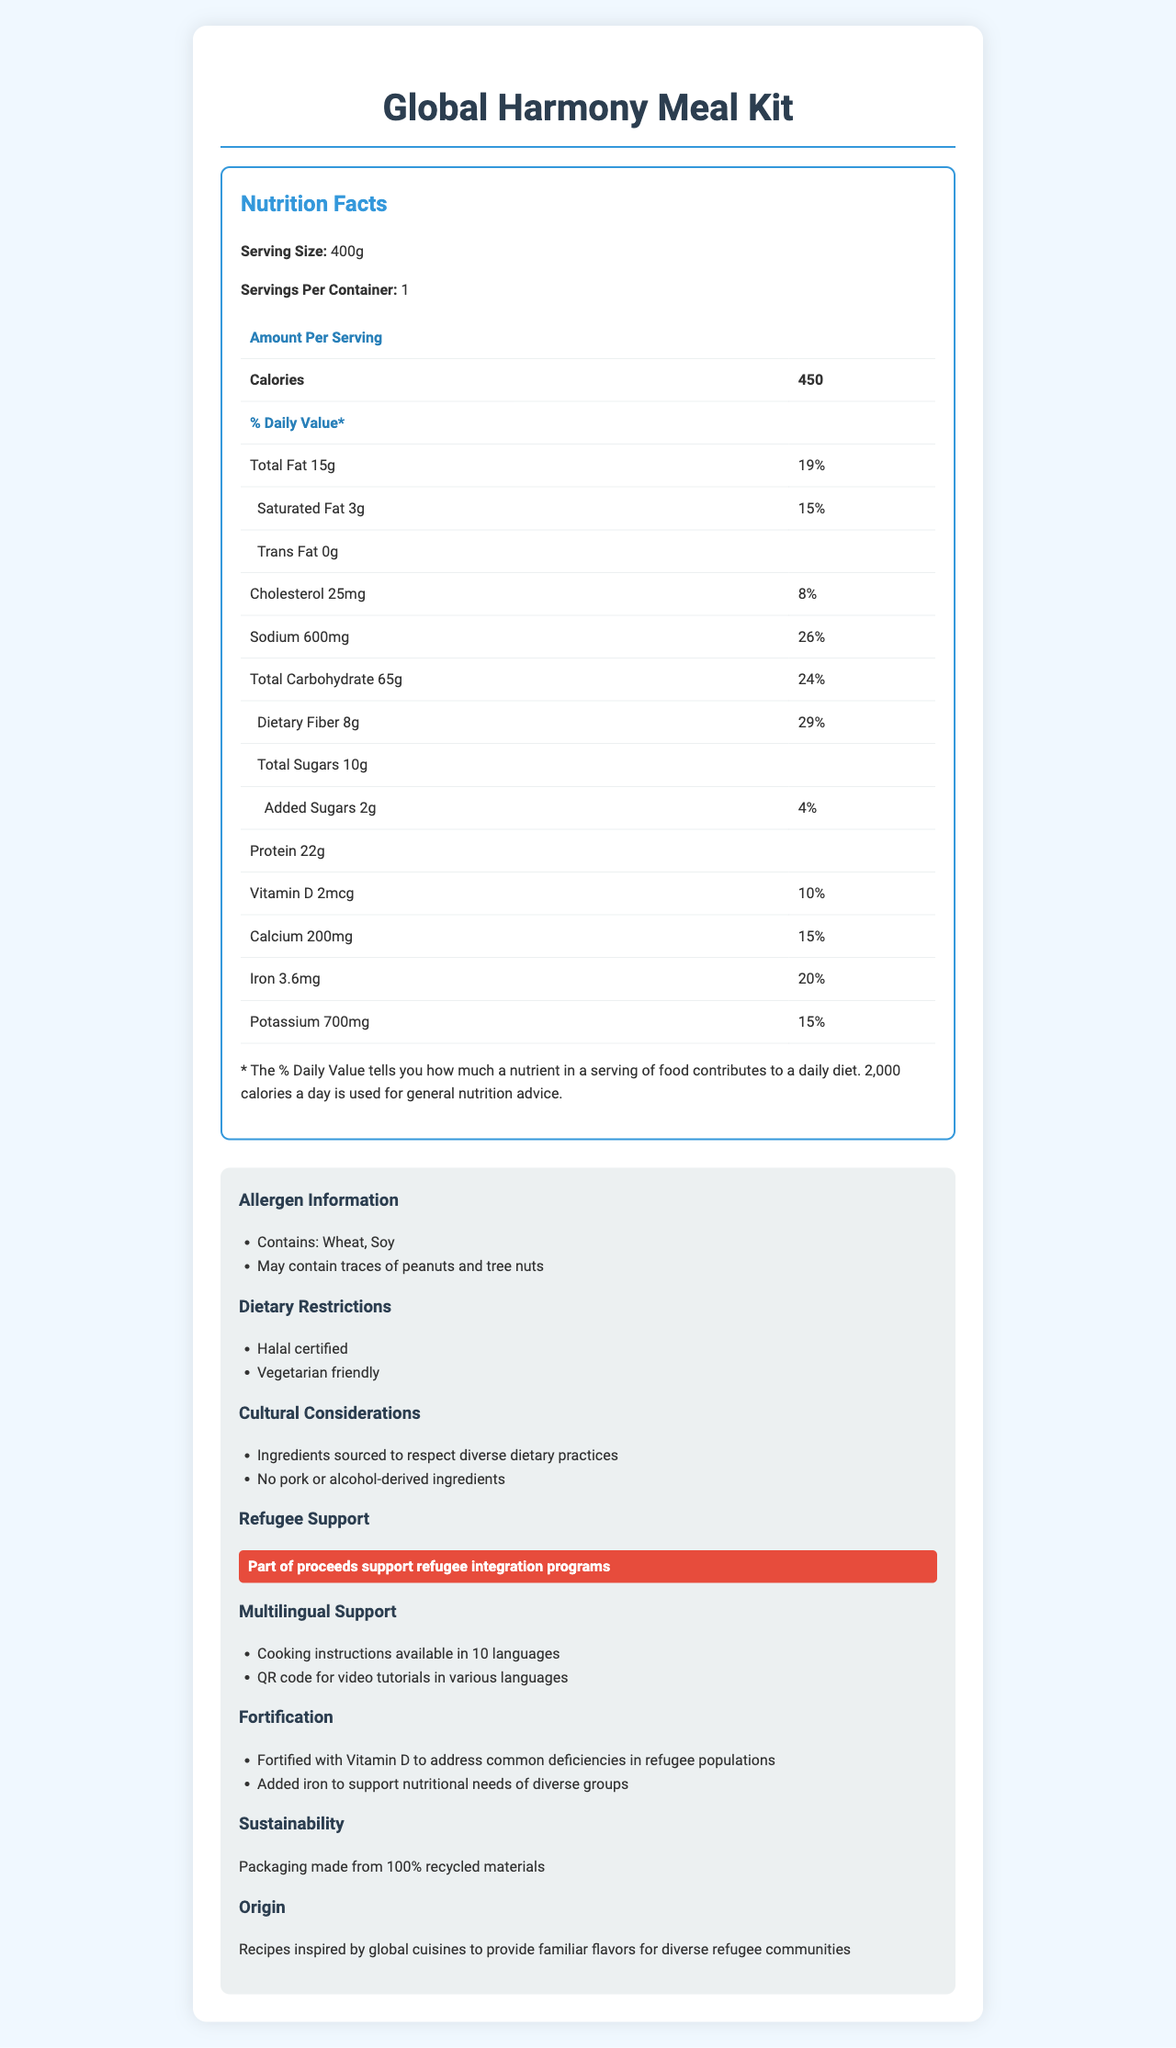what is the serving size? The serving size is indicated at the top of the Nutrition Facts section as 400g.
Answer: 400g how many calories are in one serving? The document specifies that one serving contains 450 calories.
Answer: 450 what are the primary allergens present in the product? The Allergen Information section mentions that the product contains Wheat and Soy.
Answer: Wheat, Soy is the product suitable for vegetarians? The Dietary Restrictions section includes "Vegetarian friendly," meaning it is suitable for vegetarians.
Answer: Yes what percentage of the daily value of iron does one serving provide? The Nutrition Facts table shows that one serving provides 20% of the daily value of iron.
Answer: 20% how much sodium is in one serving? The Nutrition Facts table lists the sodium content as 600mg per serving.
Answer: 600mg what fortification benefits does this product offer? The Fortification section mentions that the product is fortified with Vitamin D and added iron.
Answer: Vitamin D and Iron does the product contain alcohol-derived ingredients? The Cultural Considerations section states that there are no alcohol-derived ingredients in the product.
Answer: No how many languages are the cooking instructions available in? The Multilingual Support section mentions that cooking instructions are available in 10 languages.
Answer: 10 where are the ingredients sourced from to respect dietary practices? The Cultural Considerations section states that ingredients are sourced to respect diverse dietary practices.
Answer: Global what is the primary certification related to dietary restrictions? The Dietary Restrictions section specifies that the product is Halal certified.
Answer: Halal certified which of these allergens may be present as traces in the product? A. Dairy B. Peanuts C. Eggs The Allergen Information section states that the product may contain traces of peanuts and tree nuts.
Answer: B which nutrient has the highest percentage of daily value in one serving? A. Sodium B. Dietary Fiber C. Calcium D. Iron According to the Nutrition Facts table, dietary fiber has a daily value of 29%, higher than sodium (26%), calcium (15%), and iron (20%).
Answer: B is the packaging of the product sustainable? The Sustainability section states that the packaging is made from 100% recycled materials.
Answer: Yes does the product contribute to refugee integration programs? The Refugee Support section mentions that part of the proceeds supports refugee integration programs.
Answer: Yes describe the main idea of the document. The document outlines comprehensive details about the product, including serving size, caloric content, nutrient composition, allergen information, and dietary restrictions. It also incorporates cultural considerations, offers multilingual support, and emphasizes sustainability and support for refugee integration programs.
Answer: The document provides detailed nutritional information, allergen alerts, and cultural considerations for the "Global Harmony Meal Kit," designed to meet the dietary needs of culturally diverse refugee populations. It highlights its fortification benefits, sustainable packaging, and support for refugee integration programs, emphasizing that the meal kit is Halal certified and vegetarian friendly. what is the protein content per serving? The Nutrition Facts table indicates that one serving contains 22g of protein.
Answer: 22g can you find information about the cost of the product in the document? The document does not provide any details about the cost or price of the product.
Answer: Cannot be determined 